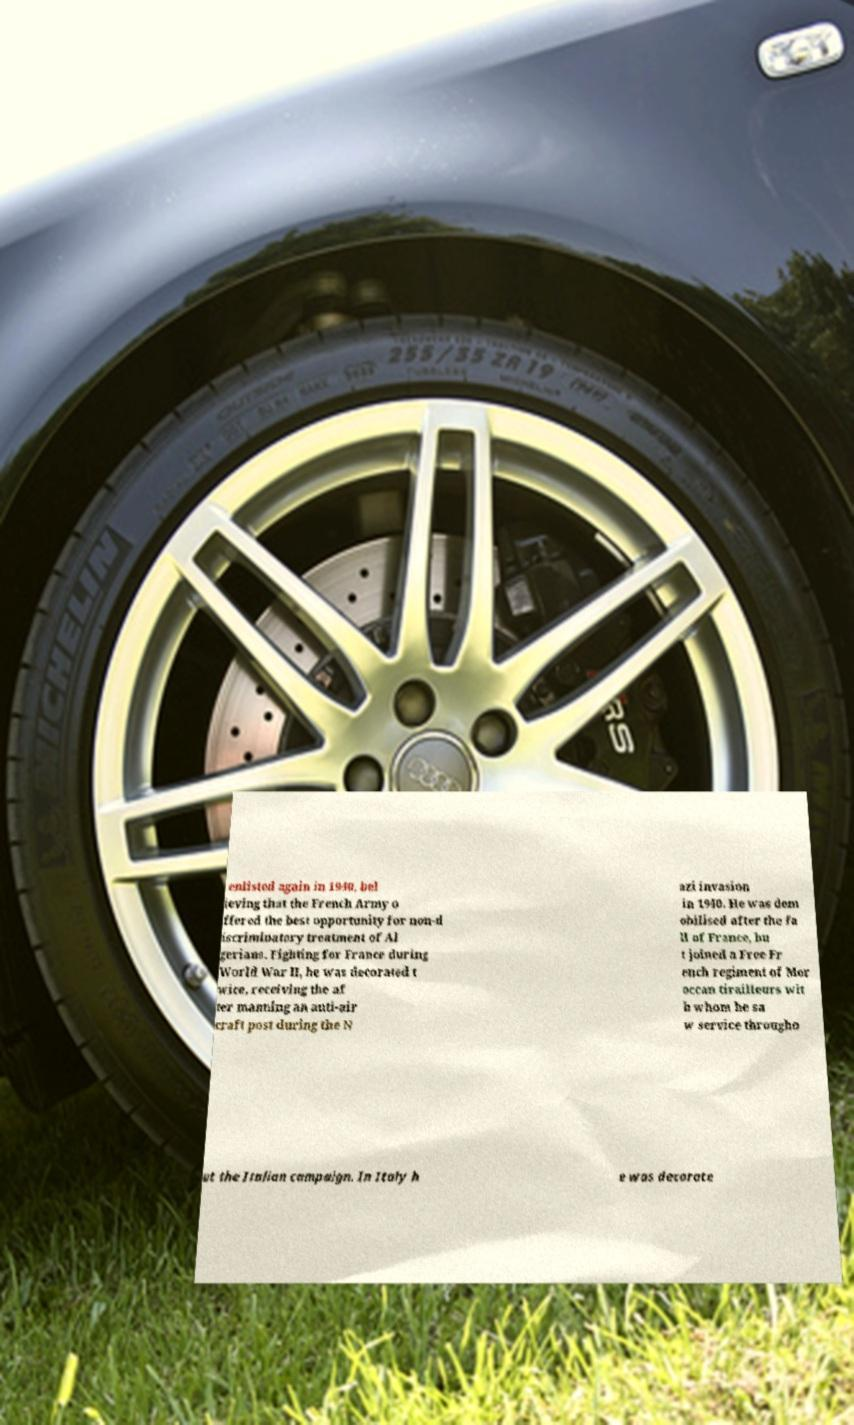Could you extract and type out the text from this image? enlisted again in 1940, bel ieving that the French Army o ffered the best opportunity for non-d iscriminatory treatment of Al gerians. Fighting for France during World War II, he was decorated t wice, receiving the af ter manning an anti-air craft post during the N azi invasion in 1940. He was dem obilised after the fa ll of France, bu t joined a Free Fr ench regiment of Mor occan tirailleurs wit h whom he sa w service througho ut the Italian campaign. In Italy h e was decorate 